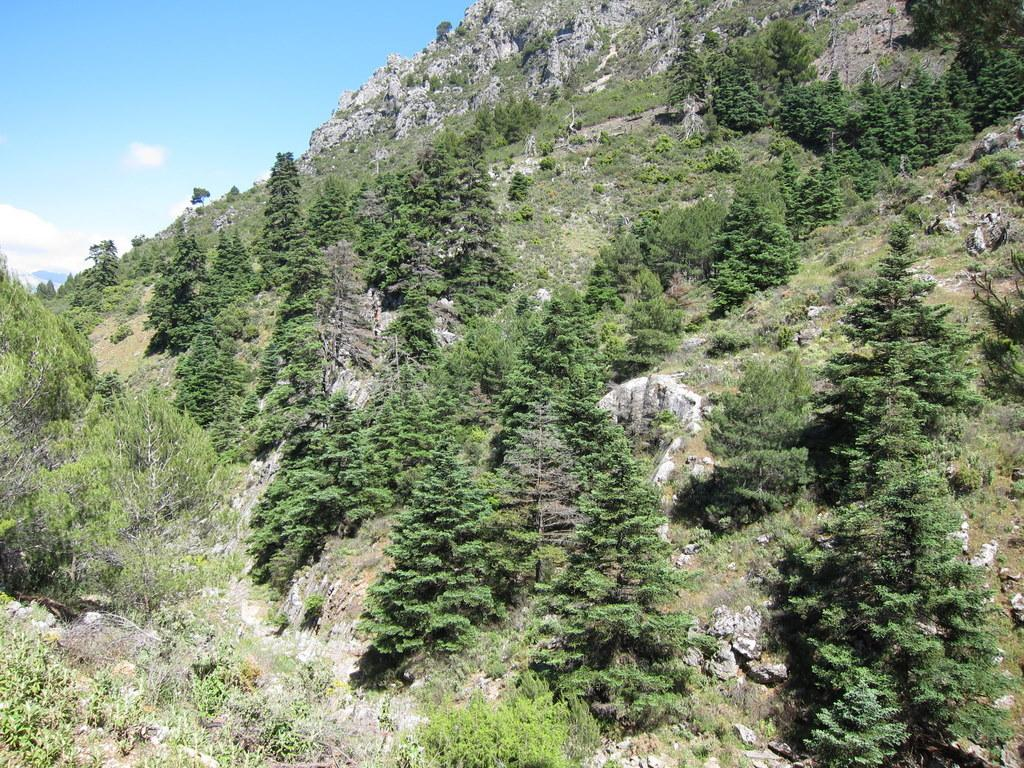What geographical feature is the main subject of the image? There is a mountain in the image. What type of vegetation can be seen on the mountain? The mountain has grass, plants, and trees. What other natural features can be seen on the mountain? The mountain has rocks. What is visible above the mountain in the image? The sky is visible in the image, and there are clouds in the sky. What type of mitten is being used to create the clouds in the image? There is no mitten present in the image, and the clouds are natural formations in the sky. Can you see a pen being used to draw the mountain in the image? There is no pen or drawing activity present in the image; it is a photograph of a real mountain. 